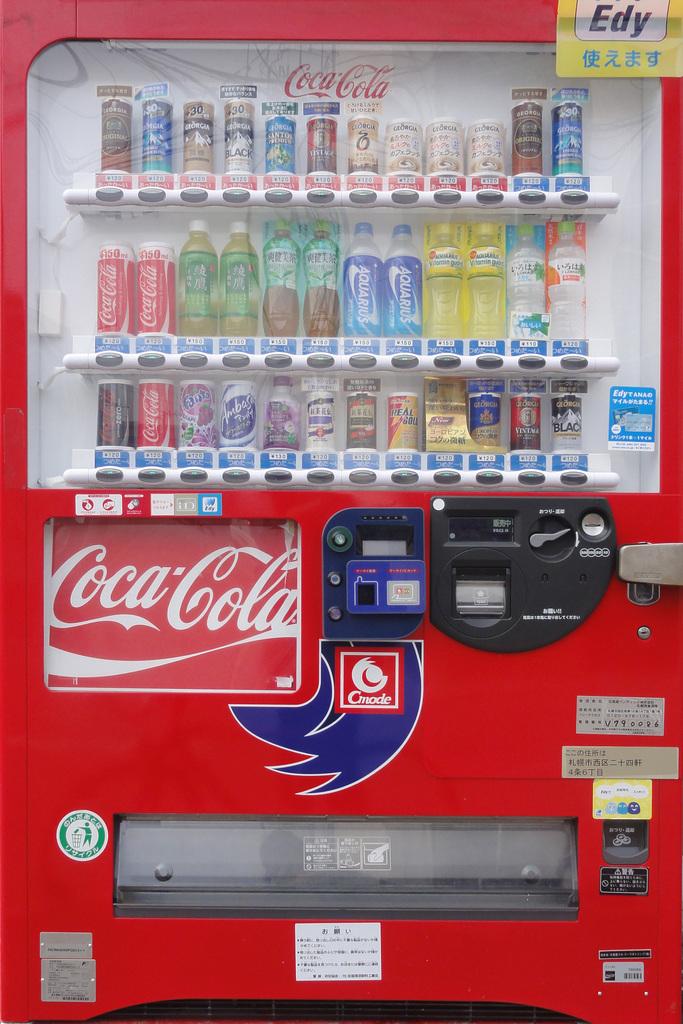Is this a coca cola vending machine?
Your answer should be very brief. Yes. Who is this vending machine made by?
Offer a terse response. Coca cola. 